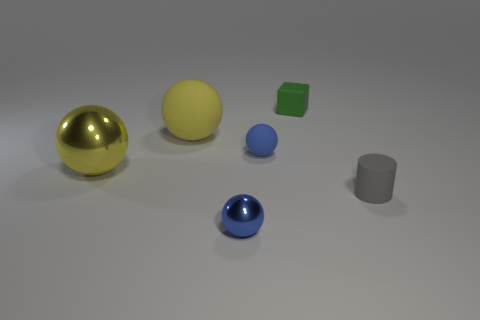Add 2 big matte balls. How many objects exist? 8 Subtract all cubes. How many objects are left? 5 Subtract 1 gray cylinders. How many objects are left? 5 Subtract all large yellow balls. Subtract all small matte things. How many objects are left? 1 Add 4 tiny gray cylinders. How many tiny gray cylinders are left? 5 Add 3 small red rubber things. How many small red rubber things exist? 3 